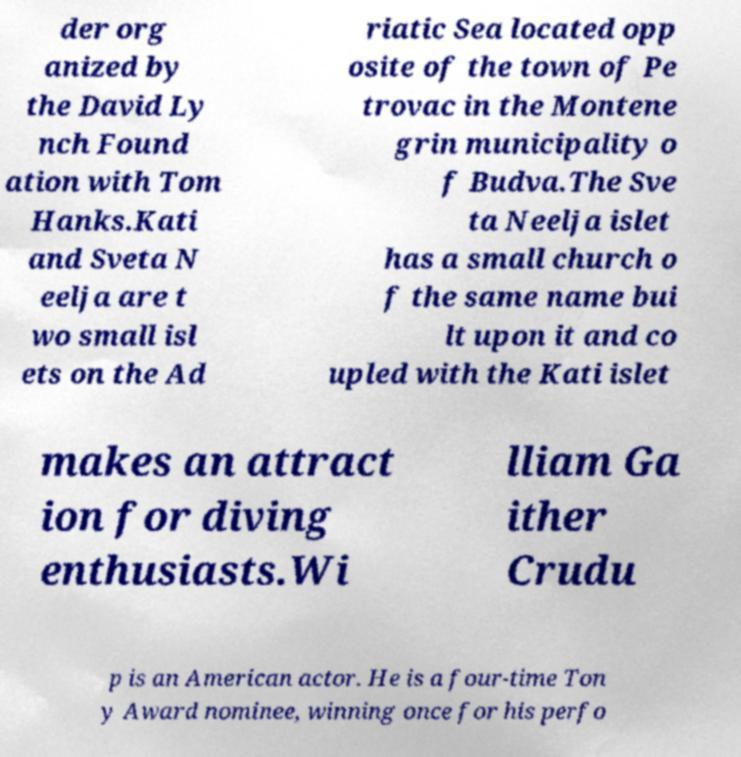What messages or text are displayed in this image? I need them in a readable, typed format. der org anized by the David Ly nch Found ation with Tom Hanks.Kati and Sveta N eelja are t wo small isl ets on the Ad riatic Sea located opp osite of the town of Pe trovac in the Montene grin municipality o f Budva.The Sve ta Neelja islet has a small church o f the same name bui lt upon it and co upled with the Kati islet makes an attract ion for diving enthusiasts.Wi lliam Ga ither Crudu p is an American actor. He is a four-time Ton y Award nominee, winning once for his perfo 